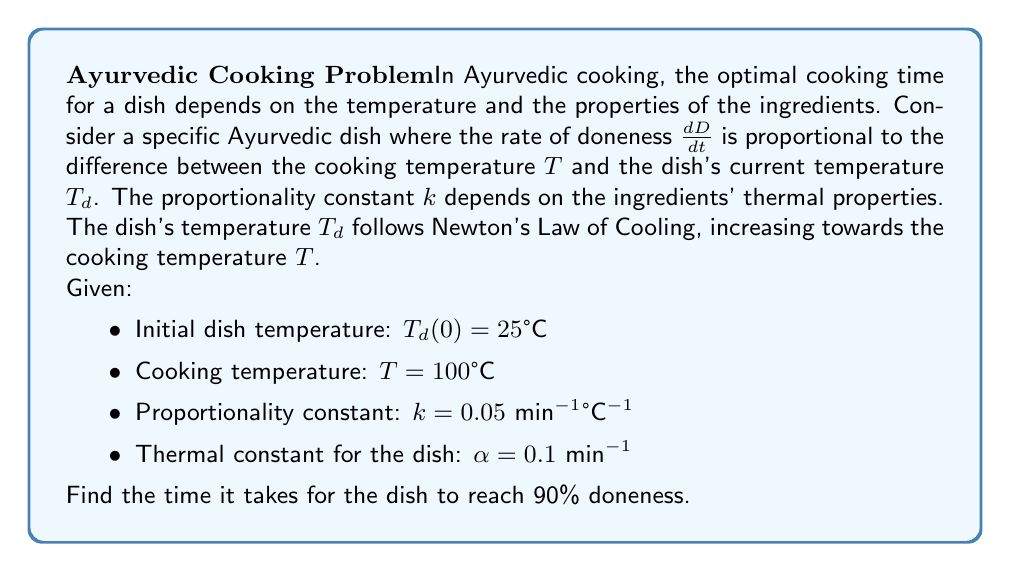Solve this math problem. To solve this problem, we need to set up and solve two differential equations:

1. For the dish's temperature $T_d$:
   $$\frac{dT_d}{dt} = \alpha(T - T_d)$$

2. For the doneness $D$:
   $$\frac{dD}{dt} = k(T - T_d)$$

Let's solve these equations step by step:

Step 1: Solve for $T_d(t)$
The solution to the first equation is:
$$T_d(t) = T + (T_d(0) - T)e^{-\alpha t}$$
$$T_d(t) = 100 + (25 - 100)e^{-0.1t} = 100 - 75e^{-0.1t}$$

Step 2: Substitute $T_d(t)$ into the second equation
$$\frac{dD}{dt} = k(T - T_d(t)) = k(100 - (100 - 75e^{-0.1t})) = 75ke^{-0.1t}$$

Step 3: Integrate to find $D(t)$
$$D(t) = \int_0^t 75ke^{-0.1\tau} d\tau = -750k(e^{-0.1t} - 1)$$
$$D(t) = 37.5(1 - e^{-0.1t})$$

Step 4: Find the time for 90% doneness
Let $D(t) = 0.9$:
$$0.9 = 37.5(1 - e^{-0.1t})$$
$$0.976 = e^{-0.1t}$$
$$\ln(0.976) = -0.1t$$
$$t = -\frac{\ln(0.976)}{0.1} \approx 0.2425 \text{ minutes}$$

Converting to seconds:
$$t \approx 0.2425 \times 60 \approx 14.55 \text{ seconds}$$
Answer: The time it takes for the Ayurvedic dish to reach 90% doneness is approximately 14.55 seconds. 